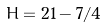<formula> <loc_0><loc_0><loc_500><loc_500>H = 2 1 - 7 / 4</formula> 